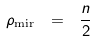<formula> <loc_0><loc_0><loc_500><loc_500>\rho _ { \text {mir} } \ = \ \frac { n } { 2 }</formula> 